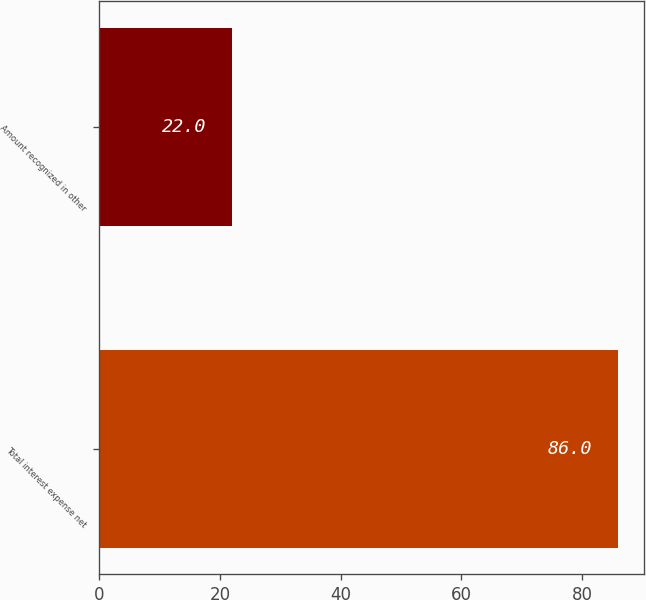Convert chart to OTSL. <chart><loc_0><loc_0><loc_500><loc_500><bar_chart><fcel>Total interest expense net<fcel>Amount recognized in other<nl><fcel>86<fcel>22<nl></chart> 